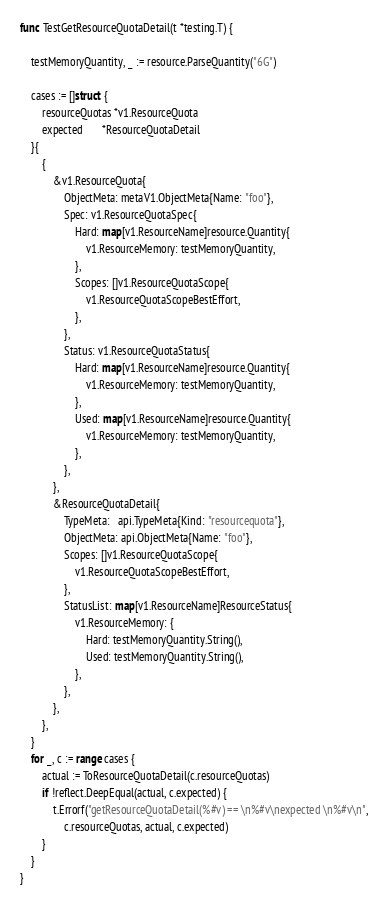Convert code to text. <code><loc_0><loc_0><loc_500><loc_500><_Go_>
func TestGetResourceQuotaDetail(t *testing.T) {

	testMemoryQuantity, _ := resource.ParseQuantity("6G")

	cases := []struct {
		resourceQuotas *v1.ResourceQuota
		expected       *ResourceQuotaDetail
	}{
		{
			&v1.ResourceQuota{
				ObjectMeta: metaV1.ObjectMeta{Name: "foo"},
				Spec: v1.ResourceQuotaSpec{
					Hard: map[v1.ResourceName]resource.Quantity{
						v1.ResourceMemory: testMemoryQuantity,
					},
					Scopes: []v1.ResourceQuotaScope{
						v1.ResourceQuotaScopeBestEffort,
					},
				},
				Status: v1.ResourceQuotaStatus{
					Hard: map[v1.ResourceName]resource.Quantity{
						v1.ResourceMemory: testMemoryQuantity,
					},
					Used: map[v1.ResourceName]resource.Quantity{
						v1.ResourceMemory: testMemoryQuantity,
					},
				},
			},
			&ResourceQuotaDetail{
				TypeMeta:   api.TypeMeta{Kind: "resourcequota"},
				ObjectMeta: api.ObjectMeta{Name: "foo"},
				Scopes: []v1.ResourceQuotaScope{
					v1.ResourceQuotaScopeBestEffort,
				},
				StatusList: map[v1.ResourceName]ResourceStatus{
					v1.ResourceMemory: {
						Hard: testMemoryQuantity.String(),
						Used: testMemoryQuantity.String(),
					},
				},
			},
		},
	}
	for _, c := range cases {
		actual := ToResourceQuotaDetail(c.resourceQuotas)
		if !reflect.DeepEqual(actual, c.expected) {
			t.Errorf("getResourceQuotaDetail(%#v) == \n%#v\nexpected \n%#v\n",
				c.resourceQuotas, actual, c.expected)
		}
	}
}
</code> 